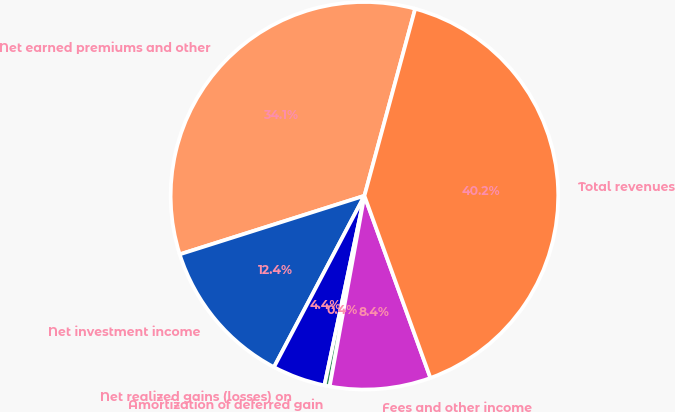Convert chart. <chart><loc_0><loc_0><loc_500><loc_500><pie_chart><fcel>Net earned premiums and other<fcel>Net investment income<fcel>Net realized gains (losses) on<fcel>Amortization of deferred gain<fcel>Fees and other income<fcel>Total revenues<nl><fcel>34.1%<fcel>12.38%<fcel>4.42%<fcel>0.44%<fcel>8.4%<fcel>40.24%<nl></chart> 